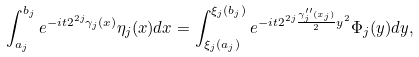<formula> <loc_0><loc_0><loc_500><loc_500>\int _ { a _ { j } } ^ { b _ { j } } e ^ { - i t 2 ^ { 2 j } \gamma _ { j } ( x ) } \eta _ { j } ( x ) d x = \int _ { \xi _ { j } ( a _ { j } ) } ^ { \xi _ { j } ( b _ { j } ) } e ^ { - i t 2 ^ { 2 j } \frac { \gamma _ { j } ^ { \prime \prime } ( x _ { j } ) } { 2 } y ^ { 2 } } \Phi _ { j } ( y ) d y ,</formula> 